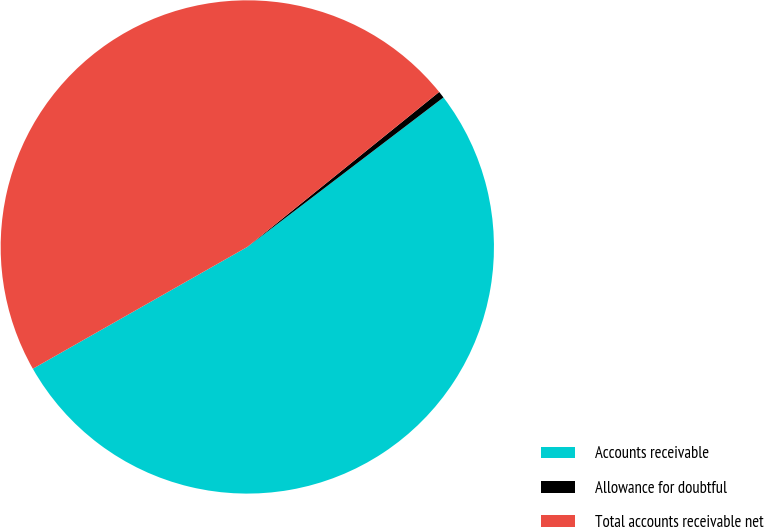Convert chart. <chart><loc_0><loc_0><loc_500><loc_500><pie_chart><fcel>Accounts receivable<fcel>Allowance for doubtful<fcel>Total accounts receivable net<nl><fcel>52.15%<fcel>0.45%<fcel>47.41%<nl></chart> 